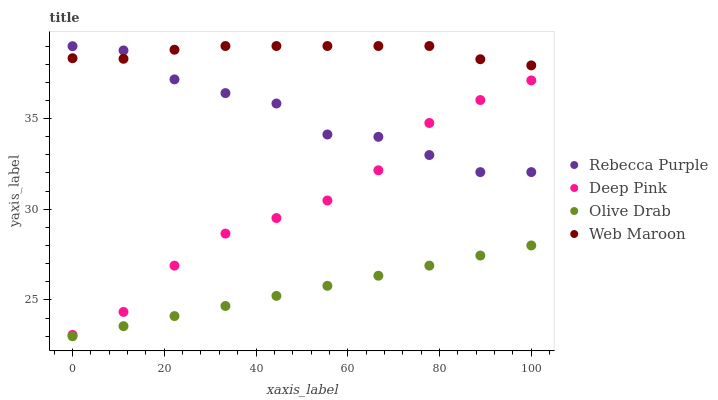Does Olive Drab have the minimum area under the curve?
Answer yes or no. Yes. Does Web Maroon have the maximum area under the curve?
Answer yes or no. Yes. Does Rebecca Purple have the minimum area under the curve?
Answer yes or no. No. Does Rebecca Purple have the maximum area under the curve?
Answer yes or no. No. Is Olive Drab the smoothest?
Answer yes or no. Yes. Is Rebecca Purple the roughest?
Answer yes or no. Yes. Is Web Maroon the smoothest?
Answer yes or no. No. Is Web Maroon the roughest?
Answer yes or no. No. Does Olive Drab have the lowest value?
Answer yes or no. Yes. Does Rebecca Purple have the lowest value?
Answer yes or no. No. Does Web Maroon have the highest value?
Answer yes or no. Yes. Does Rebecca Purple have the highest value?
Answer yes or no. No. Is Deep Pink less than Web Maroon?
Answer yes or no. Yes. Is Web Maroon greater than Deep Pink?
Answer yes or no. Yes. Does Rebecca Purple intersect Deep Pink?
Answer yes or no. Yes. Is Rebecca Purple less than Deep Pink?
Answer yes or no. No. Is Rebecca Purple greater than Deep Pink?
Answer yes or no. No. Does Deep Pink intersect Web Maroon?
Answer yes or no. No. 